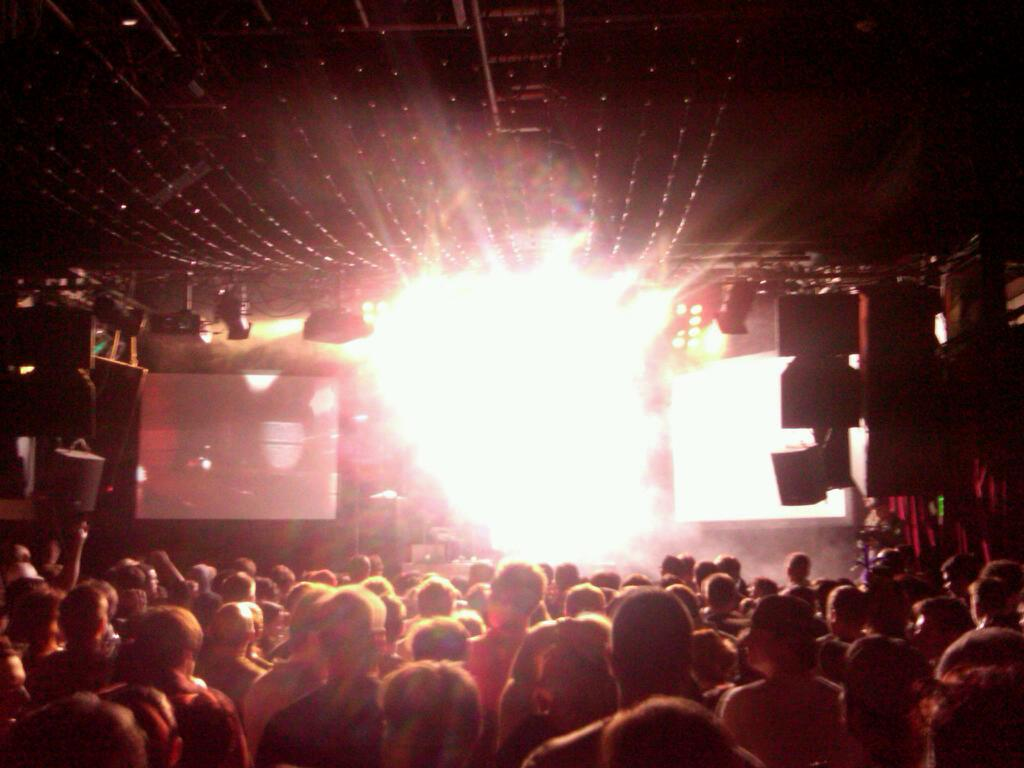How many people are in the group visible in the image? There is a group of people standing in the image, but the exact number cannot be determined without more specific information. What type of equipment is visible in the image? There are speakers visible in the image. What type of lighting is present in the image? There are lights visible in the image. What type of display devices are visible in the image? There are screens visible in the image. Can you describe any other objects present in the image? There are some objects present in the image, but their specific nature cannot be determined without more specific information. How many songs can be heard being sung by the people's eyes in the image? There is no reference to songs or the people's eyes in the image, so it is not possible to answer that question. 